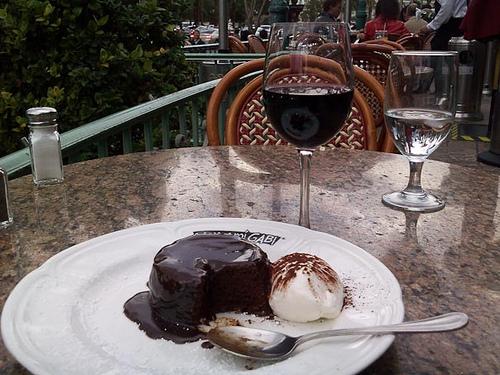Does this edible object contain high levels of sugar?
Short answer required. Yes. What is melting on the plate?
Write a very short answer. Ice cream. Do both glasses have wine?
Concise answer only. No. 